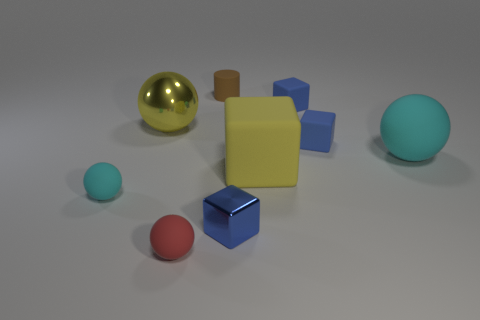There is a block that is the same color as the large metal sphere; what material is it?
Keep it short and to the point. Rubber. What is the shape of the small cyan object that is the same material as the cylinder?
Your answer should be very brief. Sphere. Is the number of big shiny things on the right side of the yellow cube less than the number of metal objects that are to the left of the tiny red rubber sphere?
Give a very brief answer. Yes. Is the number of red matte balls greater than the number of small green metal things?
Your answer should be very brief. Yes. What is the big cube made of?
Offer a very short reply. Rubber. There is a tiny thing left of the big yellow shiny object; what color is it?
Make the answer very short. Cyan. Are there more red objects that are behind the small cyan rubber thing than blue metal things left of the tiny matte cylinder?
Give a very brief answer. No. There is a yellow object on the right side of the large thing that is behind the cyan thing on the right side of the tiny cyan object; how big is it?
Ensure brevity in your answer.  Large. Are there any large balls of the same color as the big block?
Provide a succinct answer. Yes. How many blue things are there?
Your answer should be compact. 3. 